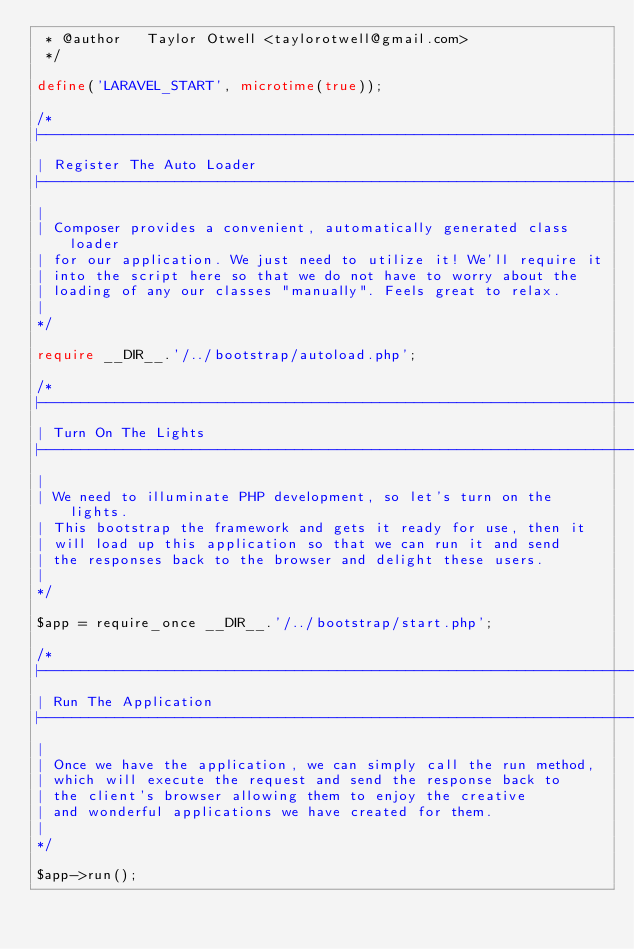Convert code to text. <code><loc_0><loc_0><loc_500><loc_500><_PHP_> * @author   Taylor Otwell <taylorotwell@gmail.com>
 */

define('LARAVEL_START', microtime(true));

/*
|--------------------------------------------------------------------------
| Register The Auto Loader
|--------------------------------------------------------------------------
|
| Composer provides a convenient, automatically generated class loader
| for our application. We just need to utilize it! We'll require it
| into the script here so that we do not have to worry about the
| loading of any our classes "manually". Feels great to relax.
|
*/

require __DIR__.'/../bootstrap/autoload.php';

/*
|--------------------------------------------------------------------------
| Turn On The Lights
|--------------------------------------------------------------------------
|
| We need to illuminate PHP development, so let's turn on the lights.
| This bootstrap the framework and gets it ready for use, then it
| will load up this application so that we can run it and send
| the responses back to the browser and delight these users.
|
*/

$app = require_once __DIR__.'/../bootstrap/start.php';

/*
|--------------------------------------------------------------------------
| Run The Application
|--------------------------------------------------------------------------
|
| Once we have the application, we can simply call the run method,
| which will execute the request and send the response back to
| the client's browser allowing them to enjoy the creative
| and wonderful applications we have created for them.
|
*/

$app->run();
</code> 